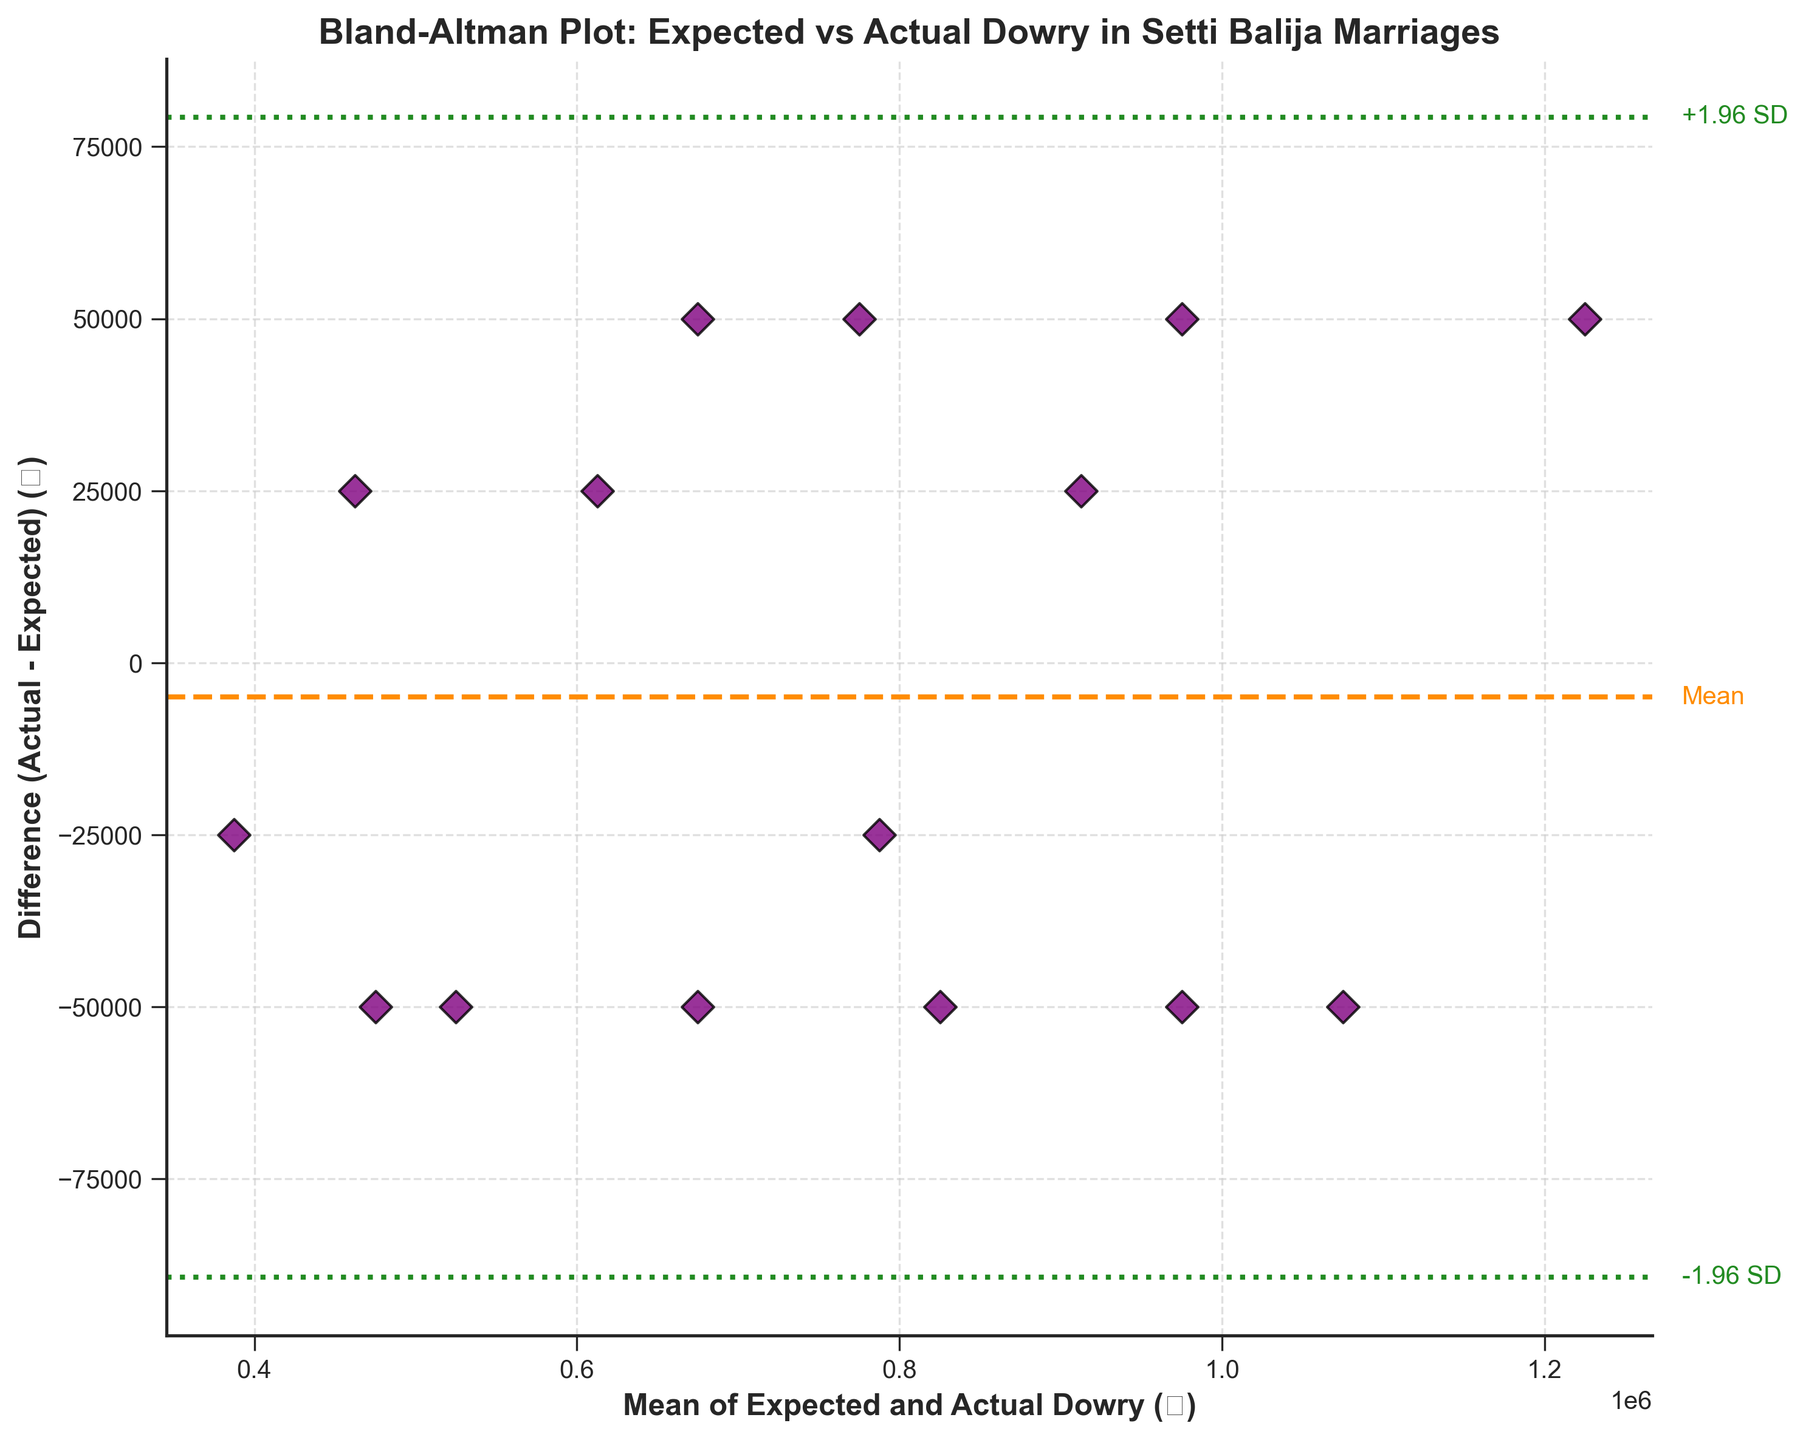How many data points are shown in the plot? Count the number of scatter points in the plot to determine the total number of data points.
Answer: 15 What is the title of the plot? The title of the plot is written at the top center of the figure.
Answer: Bland-Altman Plot: Expected vs Actual Dowry in Setti Balija Marriages What are the labels of the x-axis and y-axis? The labels of the x-axis and y-axis are provided along the respective axes.
Answer: 'Mean of Expected and Actual Dowry (₹)' and 'Difference (Actual - Expected) (₹)' What color represents the mean difference line on the plot? The mean difference line is shown with a specific color and linestyle.
Answer: Orange (dashed line) How many data points have a positive difference, where the actual dowry is higher than the expected dowry? Count the number of points above the mean difference line to determine those with a positive difference.
Answer: 7 What is the approximate mean difference (Actual - Expected) value? Look at the y-coordinate of the dashed mean difference line to find the mean difference value.
Answer: Approximately 6,666.67 What do the green dotted lines represent in the plot? The green dotted lines represent specific standard deviations from the mean difference.
Answer: +1.96 SD and -1.96 SD from the mean difference Which data point has the highest mean of expected and actual dowries? Identify the data point furthest to the right along the x-axis.
Answer: The data point with mean of 1,225,000 (expected: 1,200,000, actual: 1,250,000) Does the plot show more cases of actual dowry being higher or lower than the expected dowry? Compare the number of points above and below the mean difference line to determine the trend.
Answer: More cases of actual dowry being lower What is the approximate value of +1.96 SD from the mean difference? Identify the y-coordinate of the upper green dotted line that represents +1.96 times the standard deviation added to the mean difference.
Answer: Approximately 130,735 